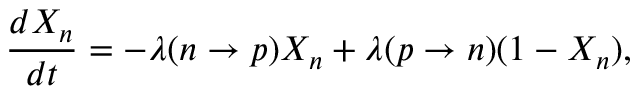<formula> <loc_0><loc_0><loc_500><loc_500>\frac { d X _ { n } } { d t } = - \lambda ( n \rightarrow p ) X _ { n } + \lambda ( p \rightarrow n ) ( 1 - X _ { n } ) ,</formula> 